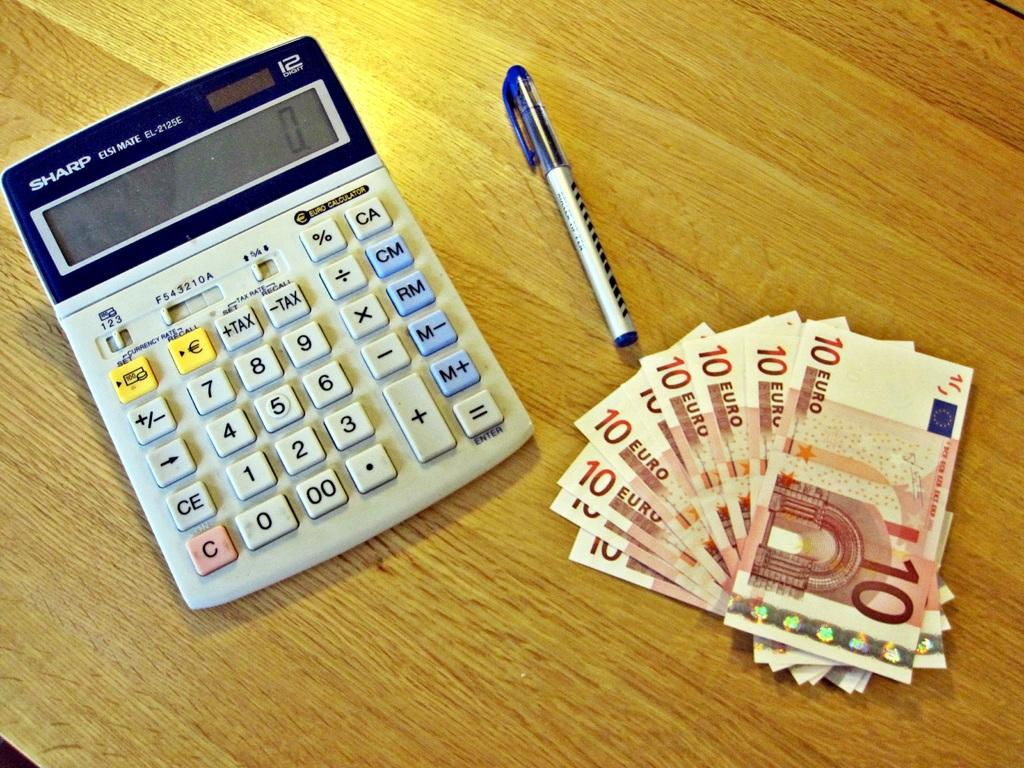<image>
Provide a brief description of the given image. A calculator that reads zero with a pen to the right of it and some 10 euro bills beneath it. 